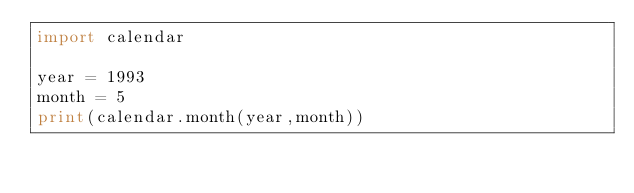Convert code to text. <code><loc_0><loc_0><loc_500><loc_500><_Python_>import calendar

year = 1993
month = 5
print(calendar.month(year,month))
</code> 